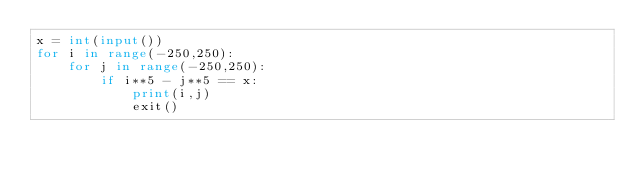Convert code to text. <code><loc_0><loc_0><loc_500><loc_500><_Python_>x = int(input())
for i in range(-250,250):
    for j in range(-250,250):
        if i**5 - j**5 == x:
            print(i,j)
            exit()</code> 